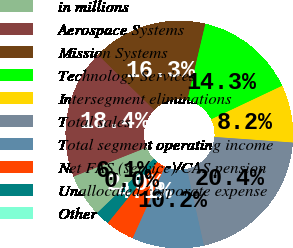Convert chart. <chart><loc_0><loc_0><loc_500><loc_500><pie_chart><fcel>in millions<fcel>Aerospace Systems<fcel>Mission Systems<fcel>Technology Services<fcel>Intersegment eliminations<fcel>Total sales<fcel>Total segment operating income<fcel>Net FAS (service)/CAS pension<fcel>Unallocated corporate expense<fcel>Other<nl><fcel>6.12%<fcel>18.37%<fcel>16.33%<fcel>14.28%<fcel>8.16%<fcel>20.41%<fcel>10.2%<fcel>4.08%<fcel>2.04%<fcel>0.0%<nl></chart> 